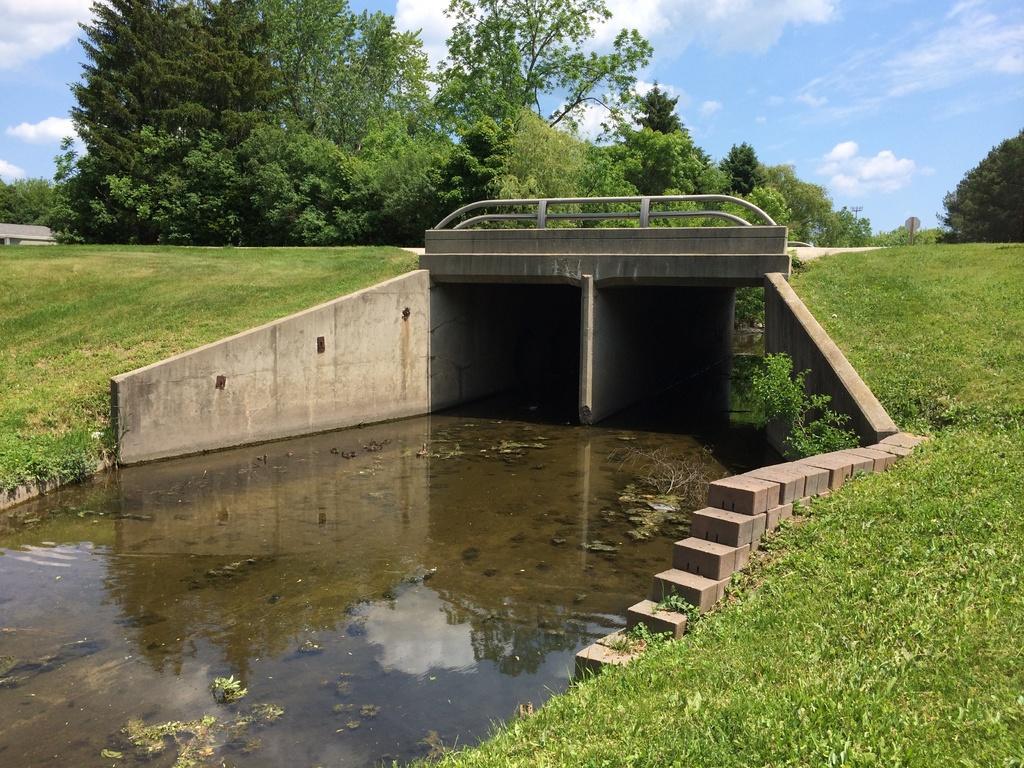Please provide a concise description of this image. In this image we can see concrete bridge, water, grass, trees, at the top we can see the sky with clouds. 